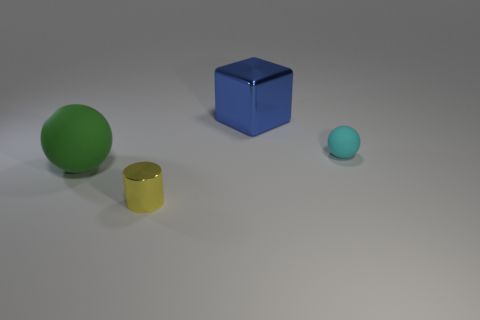Subtract 1 spheres. How many spheres are left? 1 Add 3 big metal cubes. How many objects exist? 7 Subtract all cyan spheres. How many spheres are left? 1 Subtract all cubes. How many objects are left? 3 Add 4 big blue objects. How many big blue objects are left? 5 Add 1 small spheres. How many small spheres exist? 2 Subtract 0 red balls. How many objects are left? 4 Subtract all cyan cubes. Subtract all yellow cylinders. How many cubes are left? 1 Subtract all purple cylinders. How many cyan spheres are left? 1 Subtract all objects. Subtract all small purple balls. How many objects are left? 0 